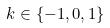Convert formula to latex. <formula><loc_0><loc_0><loc_500><loc_500>k \in \{ - 1 , 0 , 1 \}</formula> 